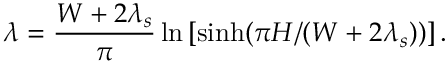<formula> <loc_0><loc_0><loc_500><loc_500>\lambda = \frac { W + 2 \lambda _ { s } } { \pi } \ln \left [ { \sinh ( \pi H / ( W + 2 \lambda _ { s } ) ) } \right ] .</formula> 